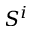Convert formula to latex. <formula><loc_0><loc_0><loc_500><loc_500>S ^ { i }</formula> 